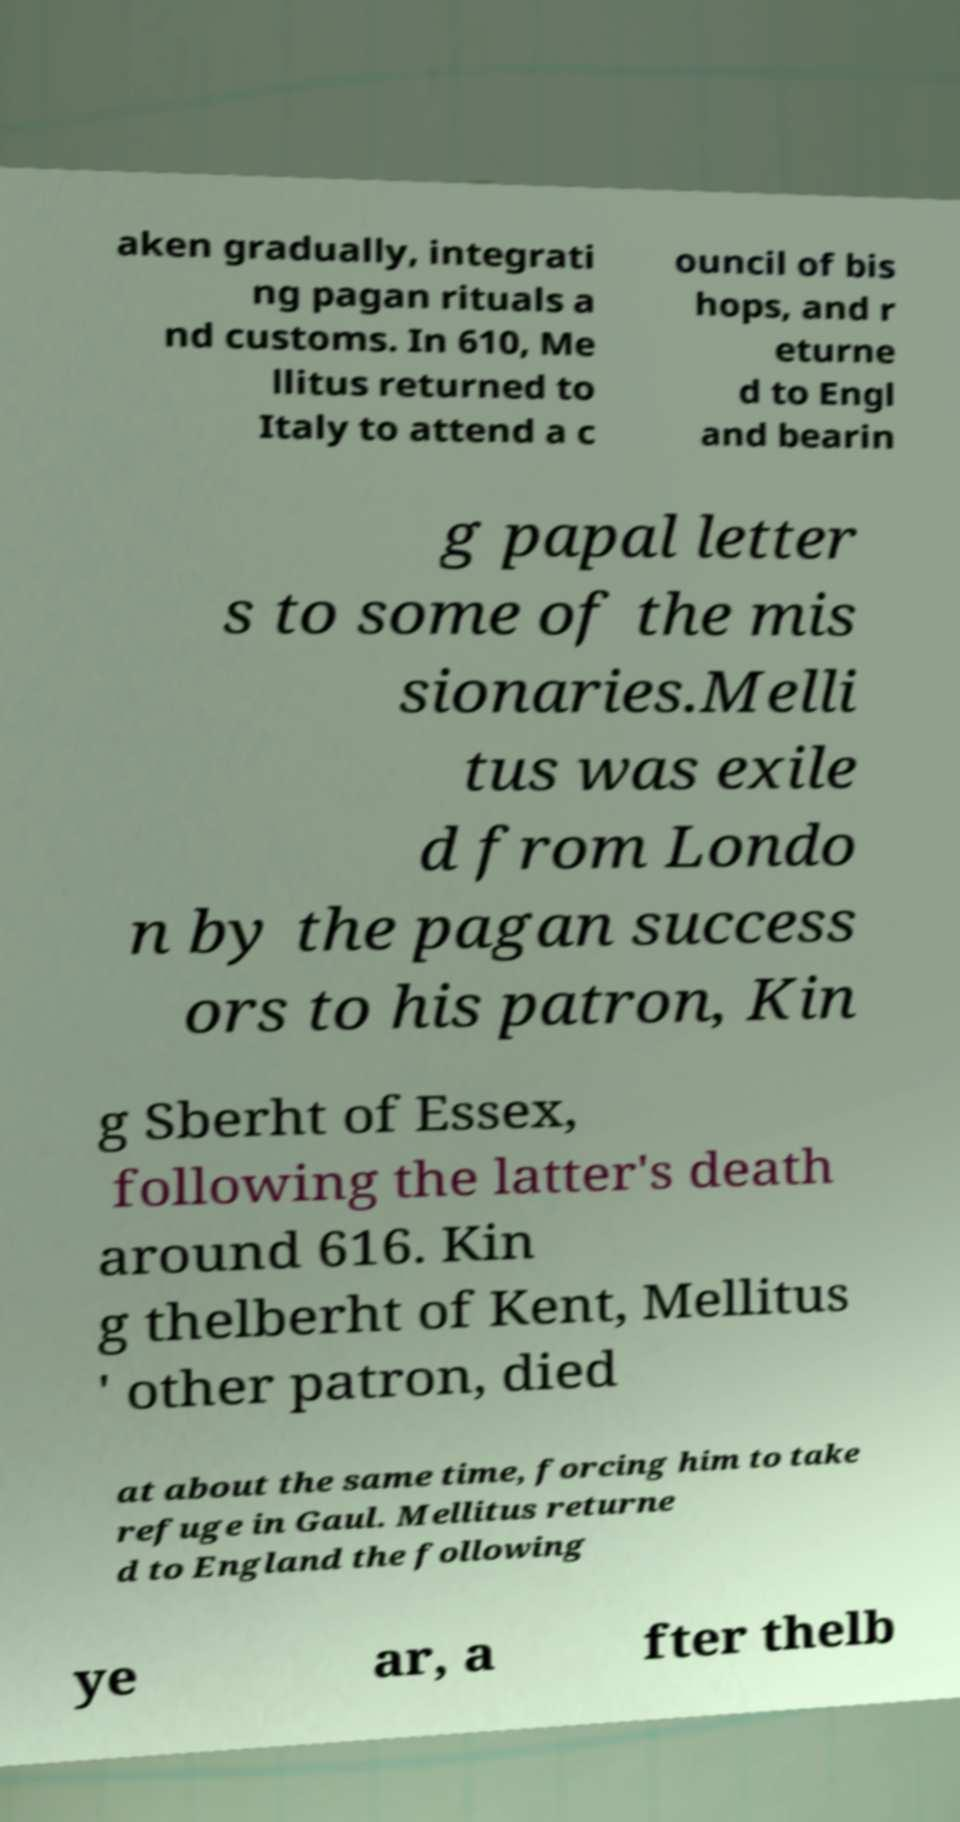For documentation purposes, I need the text within this image transcribed. Could you provide that? aken gradually, integrati ng pagan rituals a nd customs. In 610, Me llitus returned to Italy to attend a c ouncil of bis hops, and r eturne d to Engl and bearin g papal letter s to some of the mis sionaries.Melli tus was exile d from Londo n by the pagan success ors to his patron, Kin g Sberht of Essex, following the latter's death around 616. Kin g thelberht of Kent, Mellitus ' other patron, died at about the same time, forcing him to take refuge in Gaul. Mellitus returne d to England the following ye ar, a fter thelb 